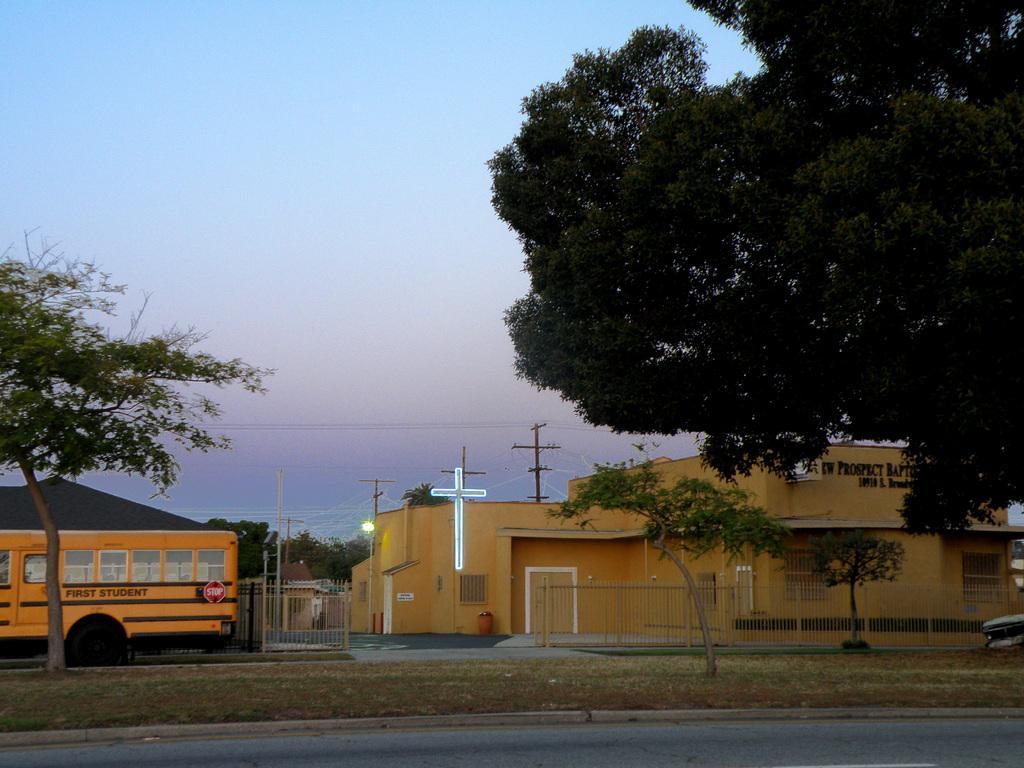In one or two sentences, can you explain what this image depicts? This image consists of a building. On the left, there is a bus. On the right, we can see a there is a trees. At the bottom, there is a road and green grass. At the top, there is sky. 